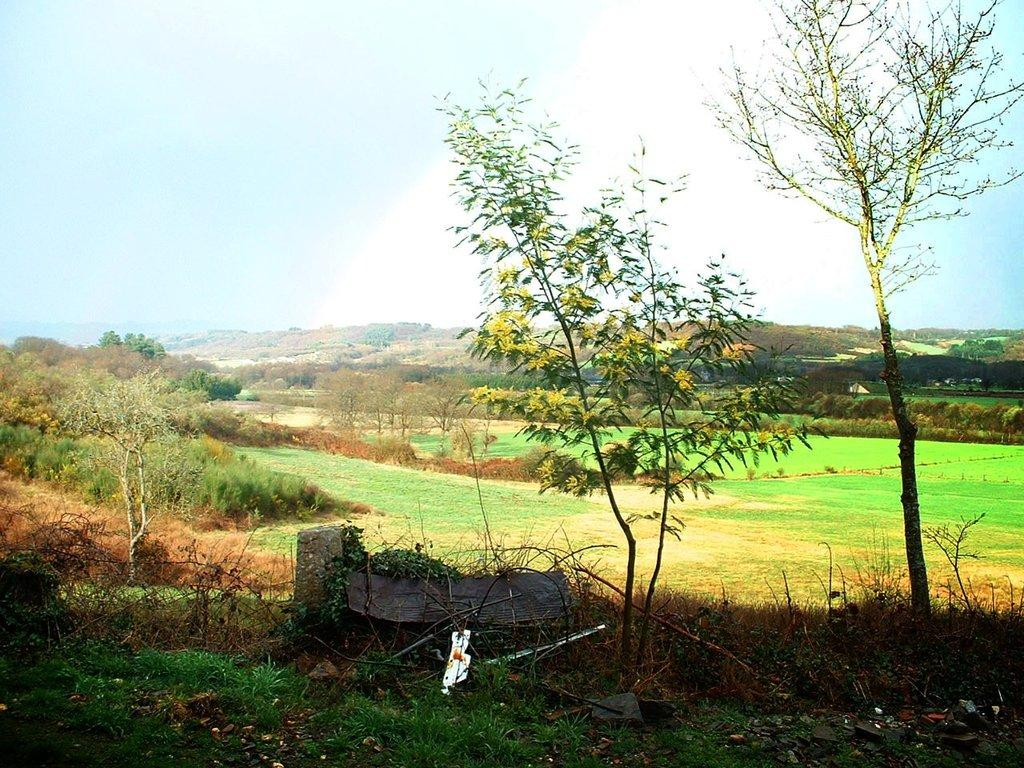What type of terrain is visible in the image? There is a grass lawn in the image. How is the grass lawn described? The grass lawn is described as beautiful. What can be seen in the background of the image? There is a hilly area with mountains in the background of the image. What type of vegetation is present at the bottom of the image? There are plants in the front bottom side of the image. What type of brush is used to paint the banana in the image? There is no brush or banana present in the image; it features a grass lawn, mountains, and plants. 